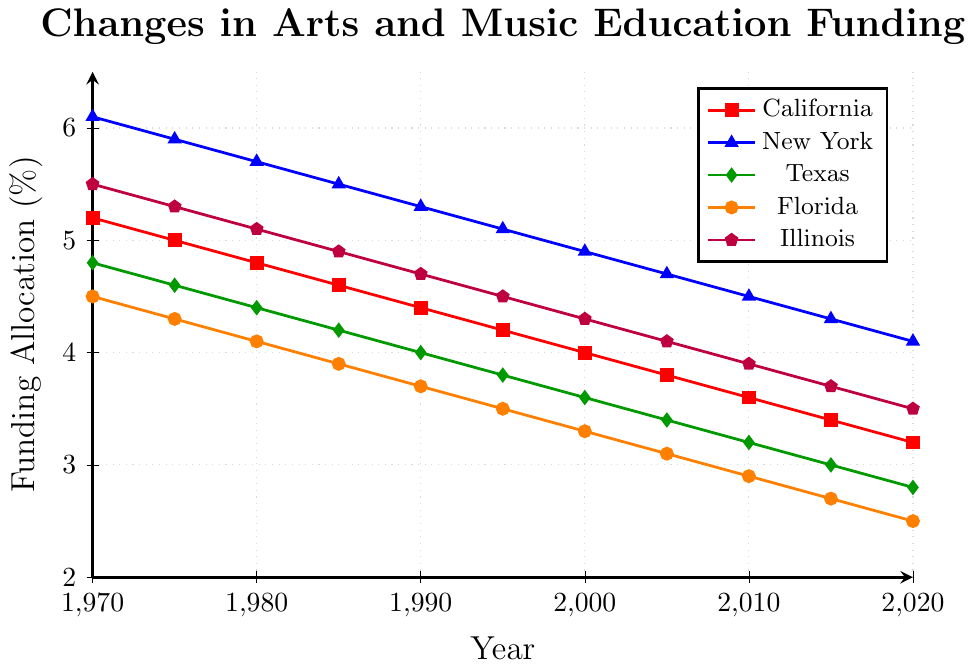What was the funding allocation for arts and music education in California in 1970 compared to 2020? In 1970, the funding allocation for California was 5.2%. In 2020, the allocation dropped to 3.2%. The change can be observed by looking at the data points corresponding to California for the years 1970 and 2020.
Answer: It decreased from 5.2% to 3.2% What is the overall trend of funding allocation for New York over the 50 years? The trend for New York shows a consistent decrease from 6.1% in 1970 to 4.1% in 2020. The data points show a steady decline over the years.
Answer: The trend is decreasing Which state had the highest funding allocation in 2020? To determine this, we compare the 2020 funding values for all states. New York had the highest allocation in 2020 at 4.1%.
Answer: New York By how much did the funding allocation for Texas change from 1980 to 2020? In 1980, the allocation for Texas was 4.4%. By 2020, it had decreased to 2.8%. The change can be calculated as 4.4% - 2.8%.
Answer: It decreased by 1.6% Which state experienced the greatest absolute decrease in funding allocation over the 50 years? To find this, we compare the initial and final funding values for each state and calculate the absolute differences. New York went from 6.1% to 4.1%, a decrease of 2%.
Answer: New York What was the funding allocation for Florida in 1985? Looking at the data for the year 1985, Florida's funding allocation was 3.9%.
Answer: 3.9% Compare the average funding allocation from 1990 to 2020 for Illinois and Texas. We calculate the average for each state over the period. For Illinois: (4.7+4.5+4.3+4.1+3.9+3.7+3.5)/7. For Texas: (4.0+3.8+3.6+3.4+3.2+3.0+2.8)/7.
Answer: Illinois: 4.1%, Texas: 3.4% Which state had the smallest allocation in 1990? Comparing the 1990 funding values, Florida had the smallest allocation at 3.7%.
Answer: Florida Which state had the most consistent funding allocation over the years? To determine consistency, we look for the state with the smallest changes or variations in funding. Illinois' values show relatively small changes compared to other states.
Answer: Illinois 